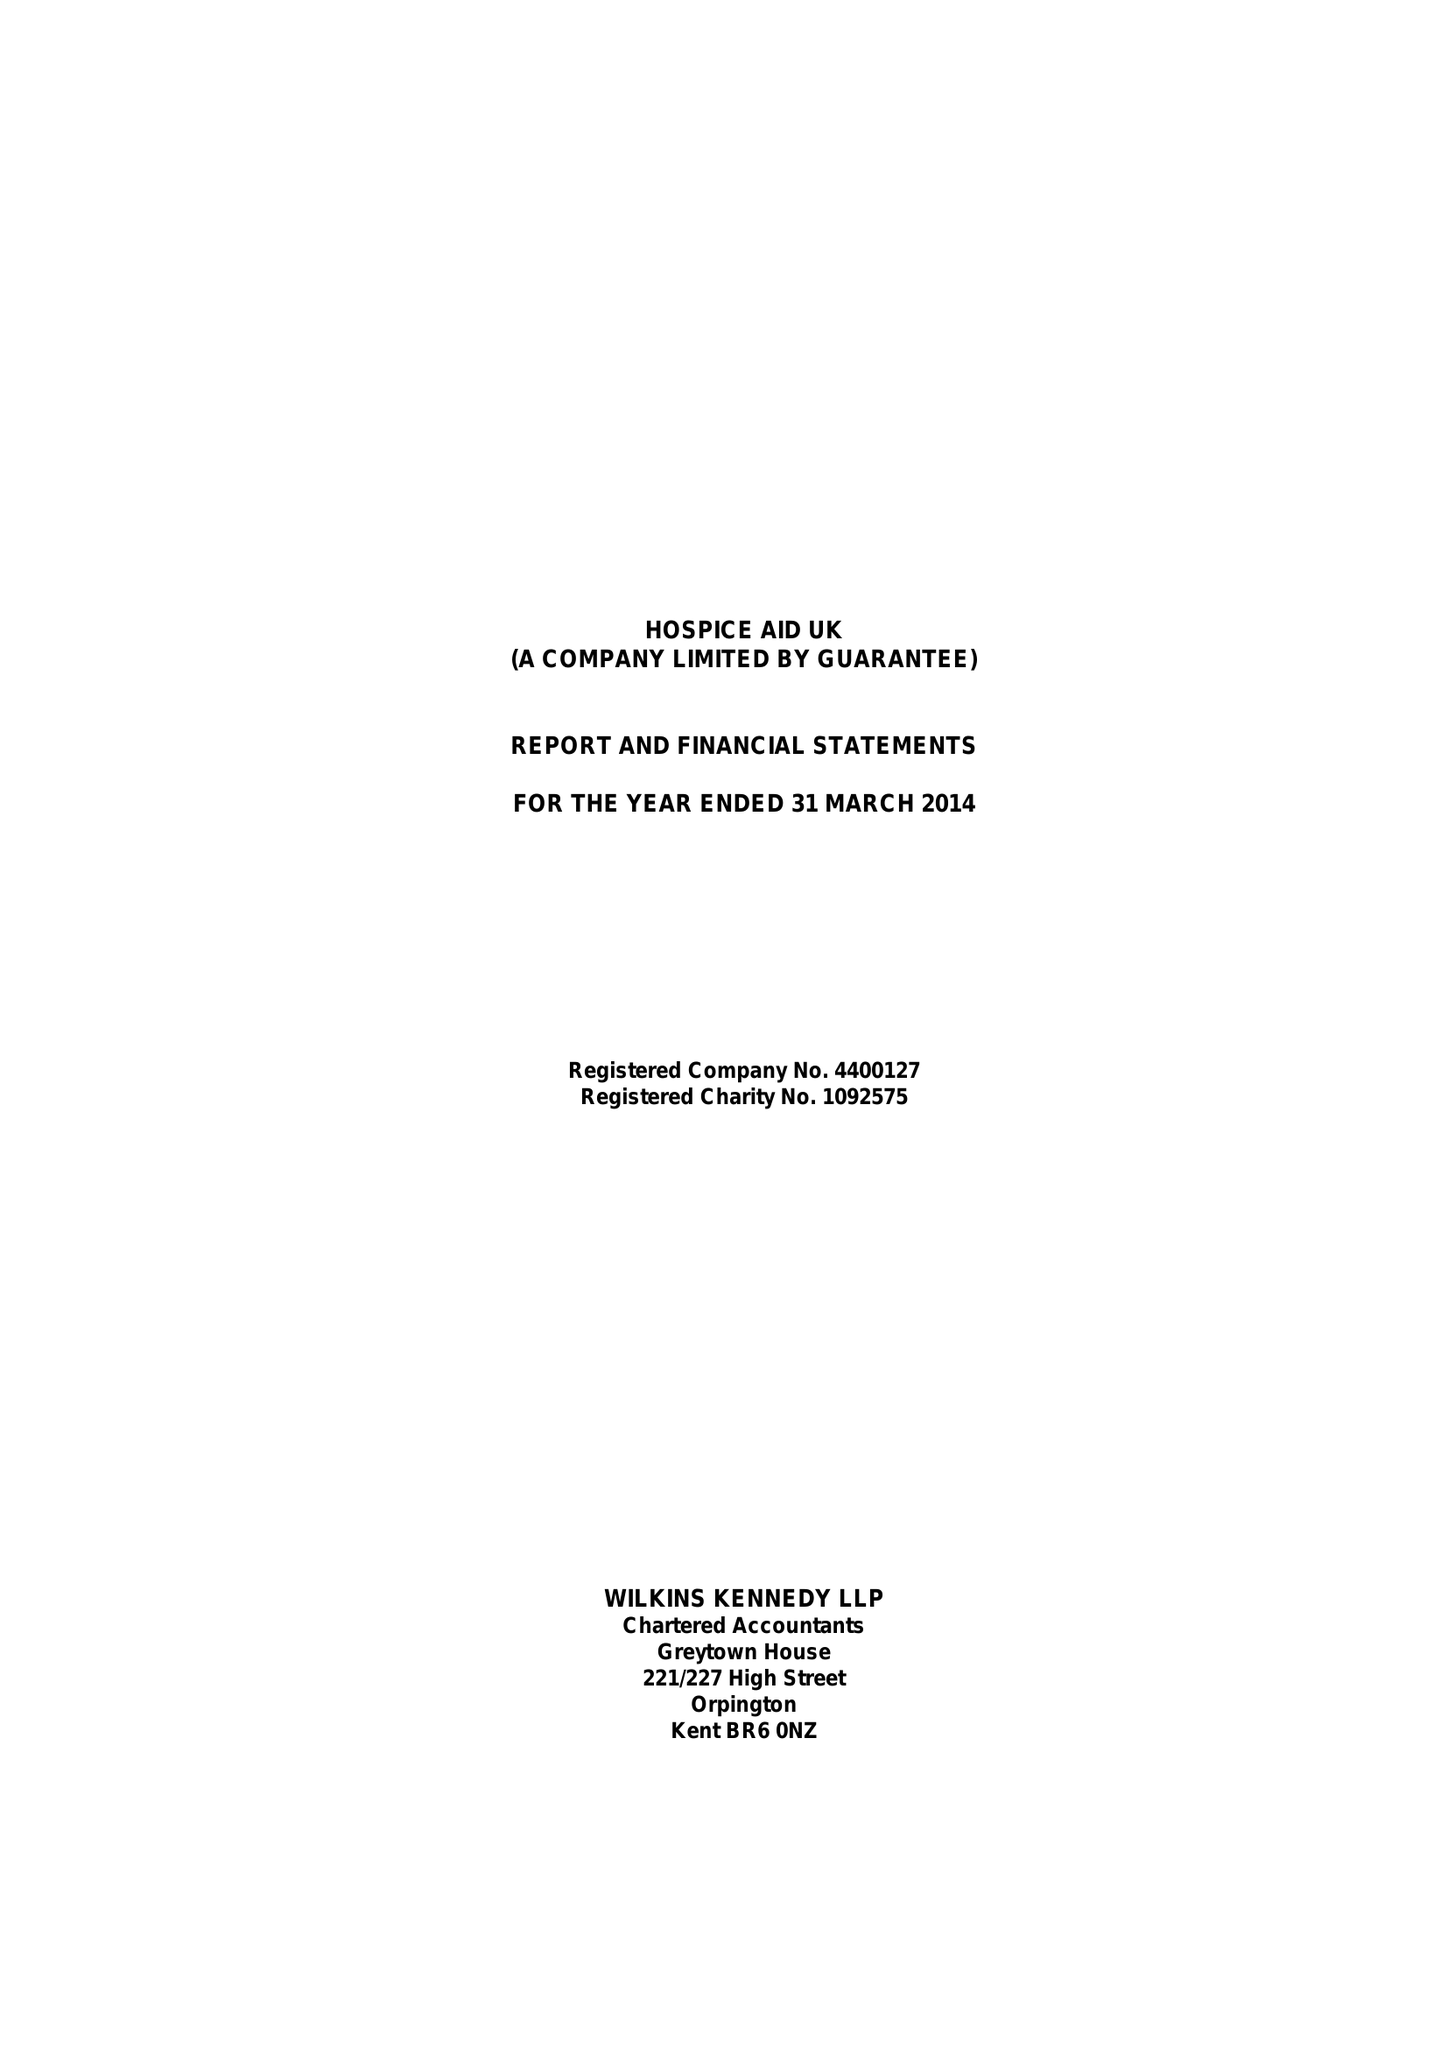What is the value for the address__postcode?
Answer the question using a single word or phrase. RH10 1HT 